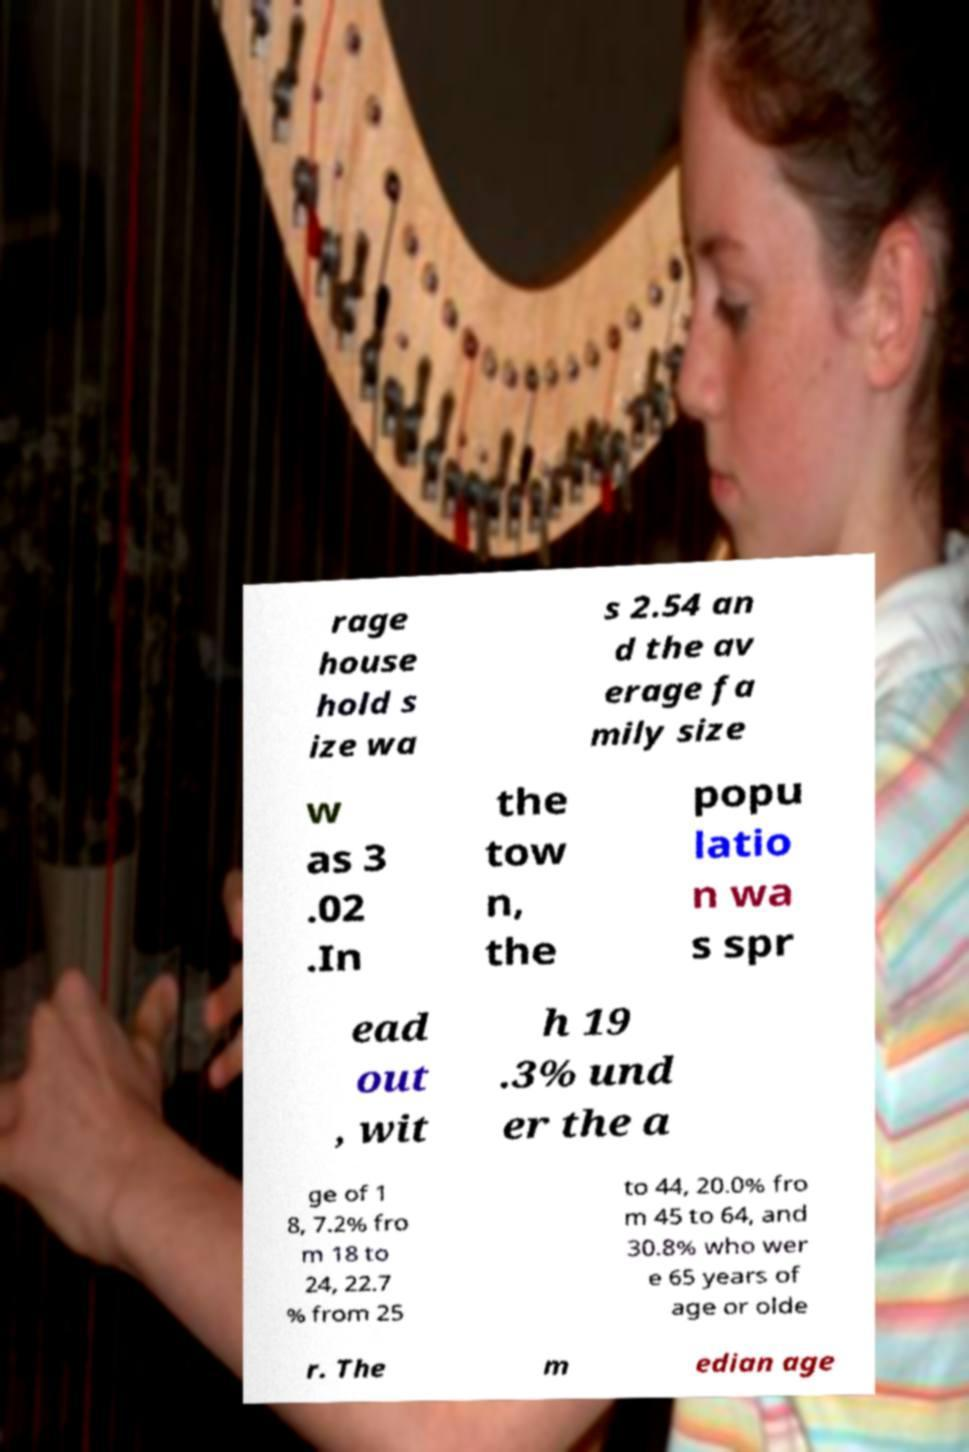What messages or text are displayed in this image? I need them in a readable, typed format. rage house hold s ize wa s 2.54 an d the av erage fa mily size w as 3 .02 .In the tow n, the popu latio n wa s spr ead out , wit h 19 .3% und er the a ge of 1 8, 7.2% fro m 18 to 24, 22.7 % from 25 to 44, 20.0% fro m 45 to 64, and 30.8% who wer e 65 years of age or olde r. The m edian age 